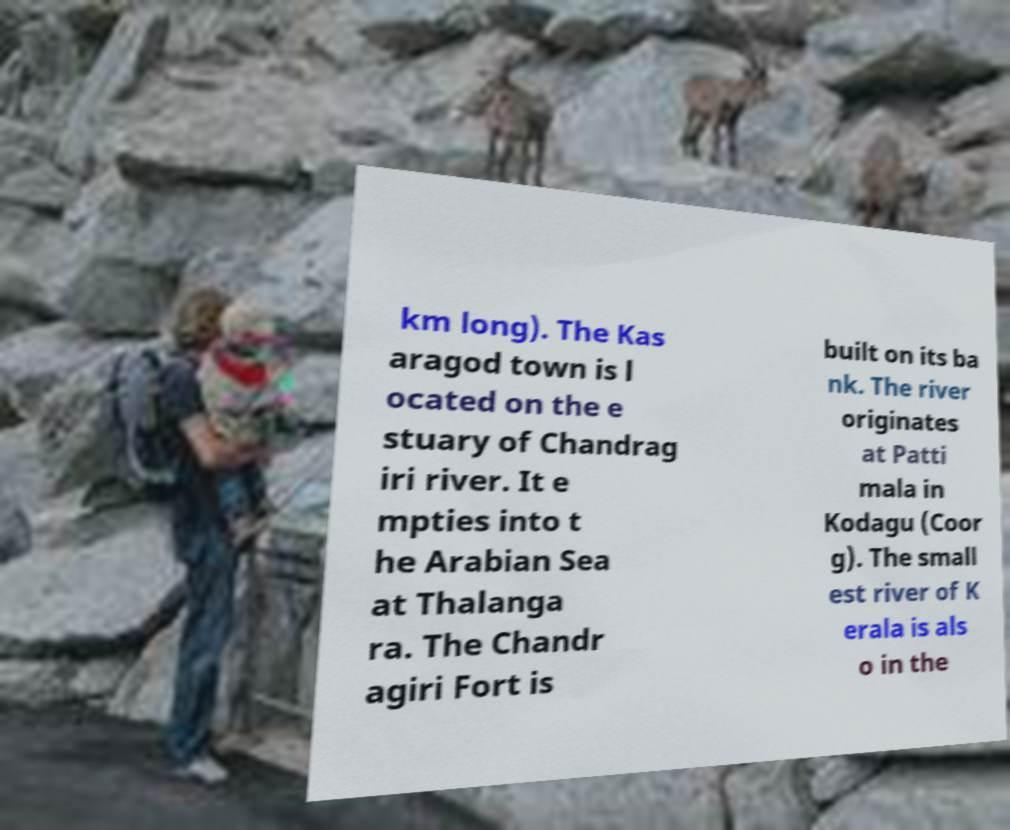There's text embedded in this image that I need extracted. Can you transcribe it verbatim? km long). The Kas aragod town is l ocated on the e stuary of Chandrag iri river. It e mpties into t he Arabian Sea at Thalanga ra. The Chandr agiri Fort is built on its ba nk. The river originates at Patti mala in Kodagu (Coor g). The small est river of K erala is als o in the 